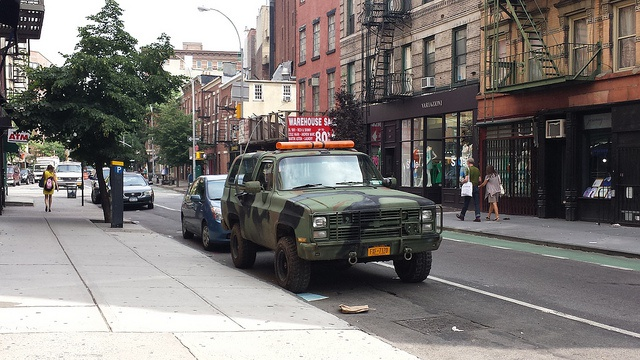Describe the objects in this image and their specific colors. I can see truck in black, gray, darkgray, and lightgray tones, car in black, gray, and lightgray tones, car in black, lightgray, darkgray, and gray tones, people in black, gray, and darkgray tones, and people in black, darkgray, lightgray, and gray tones in this image. 